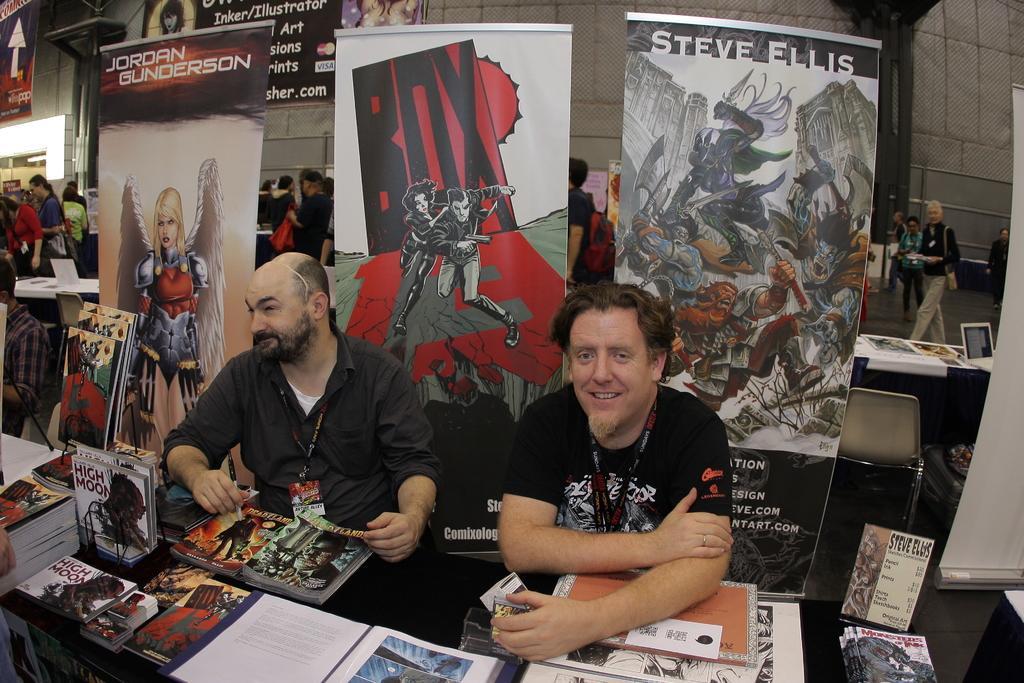Please provide a concise description of this image. This picture is taken inside the room. In this image, in the middle, we can see two men are sitting on the chair in front of the table, on the table, we can see some books and a boat. On the boat, we can see some pictures and some text written on it. On the right side, we can also see a group of people. In the background, we can see some hoardings. On the right side, we can also see a group of people, table and a chair. In the background, we can also see some hoardings and a wall. 